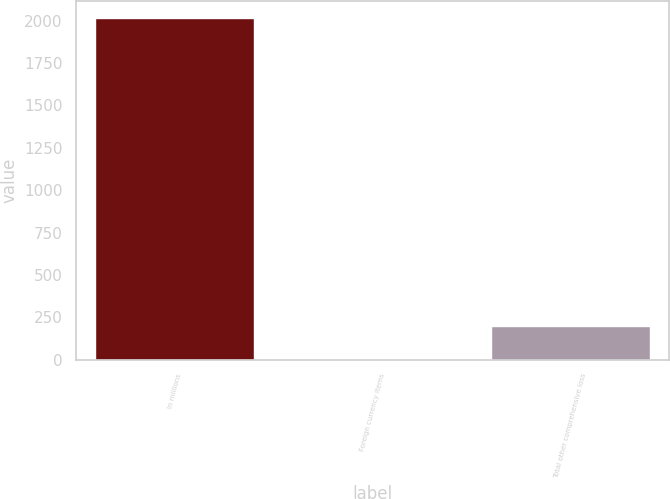Convert chart. <chart><loc_0><loc_0><loc_500><loc_500><bar_chart><fcel>In millions<fcel>Foreign currency items<fcel>Total other comprehensive loss<nl><fcel>2016<fcel>0.4<fcel>201.96<nl></chart> 